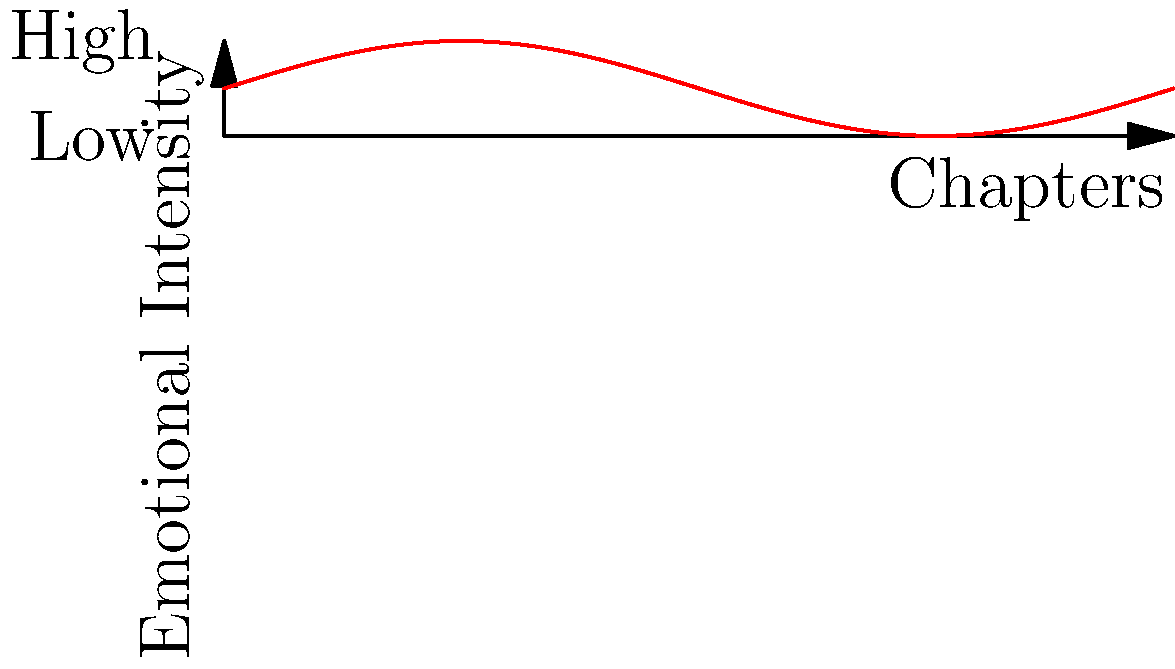In Naum Prifti's novel "Nëpër Ankthin e Viteve" (Through the Anguish of Years), the emotional intensity fluctuates throughout the chapters as shown in the graph. At which chapter does the emotional tone reach its second peak? To answer this question, we need to analyze the graph of emotional intensity throughout the chapters of Prifti's novel:

1. The x-axis represents the chapters, ranging from 0 to 10.
2. The y-axis represents the emotional intensity, with "Low" at the bottom and "High" at the top.
3. The red curve shows the fluctuation of emotional intensity across the chapters.
4. We can see that the curve has multiple peaks and valleys.
5. The first peak occurs around chapter 2.5.
6. Moving along the x-axis, we observe the second peak occurring at approximately chapter 7.5.

Therefore, the second peak in emotional intensity is reached near chapter 7.5 of the novel.
Answer: Chapter 7.5 